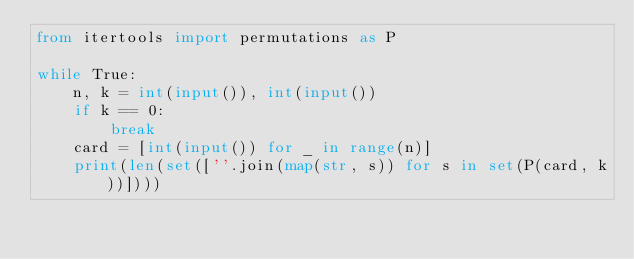Convert code to text. <code><loc_0><loc_0><loc_500><loc_500><_Python_>from itertools import permutations as P

while True:
    n, k = int(input()), int(input())
    if k == 0:
        break
    card = [int(input()) for _ in range(n)]
    print(len(set([''.join(map(str, s)) for s in set(P(card, k))])))</code> 